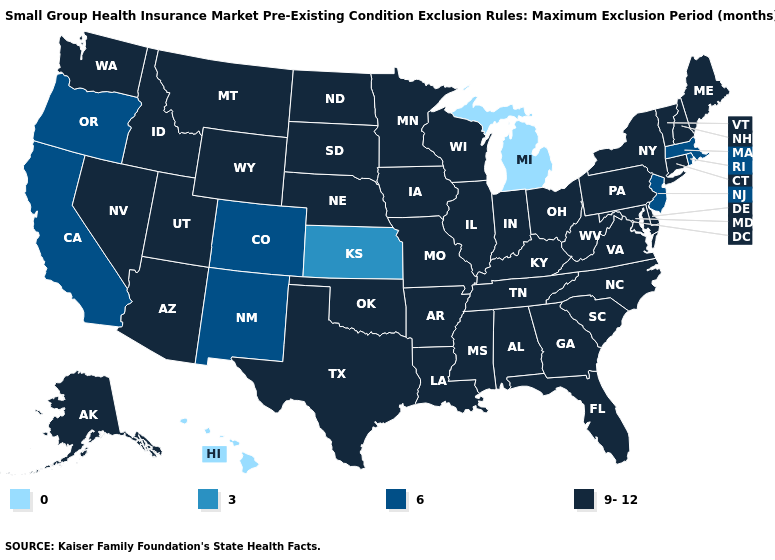Does Maryland have the same value as Georgia?
Give a very brief answer. Yes. How many symbols are there in the legend?
Concise answer only. 4. What is the value of New Jersey?
Concise answer only. 6. What is the highest value in states that border Wyoming?
Short answer required. 9-12. What is the highest value in the USA?
Be succinct. 9-12. Name the states that have a value in the range 9-12?
Concise answer only. Alabama, Alaska, Arizona, Arkansas, Connecticut, Delaware, Florida, Georgia, Idaho, Illinois, Indiana, Iowa, Kentucky, Louisiana, Maine, Maryland, Minnesota, Mississippi, Missouri, Montana, Nebraska, Nevada, New Hampshire, New York, North Carolina, North Dakota, Ohio, Oklahoma, Pennsylvania, South Carolina, South Dakota, Tennessee, Texas, Utah, Vermont, Virginia, Washington, West Virginia, Wisconsin, Wyoming. Name the states that have a value in the range 3?
Keep it brief. Kansas. Does Connecticut have the lowest value in the USA?
Concise answer only. No. What is the highest value in the Northeast ?
Short answer required. 9-12. What is the highest value in the USA?
Quick response, please. 9-12. Is the legend a continuous bar?
Concise answer only. No. Name the states that have a value in the range 9-12?
Quick response, please. Alabama, Alaska, Arizona, Arkansas, Connecticut, Delaware, Florida, Georgia, Idaho, Illinois, Indiana, Iowa, Kentucky, Louisiana, Maine, Maryland, Minnesota, Mississippi, Missouri, Montana, Nebraska, Nevada, New Hampshire, New York, North Carolina, North Dakota, Ohio, Oklahoma, Pennsylvania, South Carolina, South Dakota, Tennessee, Texas, Utah, Vermont, Virginia, Washington, West Virginia, Wisconsin, Wyoming. Name the states that have a value in the range 3?
Keep it brief. Kansas. Name the states that have a value in the range 3?
Short answer required. Kansas. Does Connecticut have the lowest value in the Northeast?
Give a very brief answer. No. 